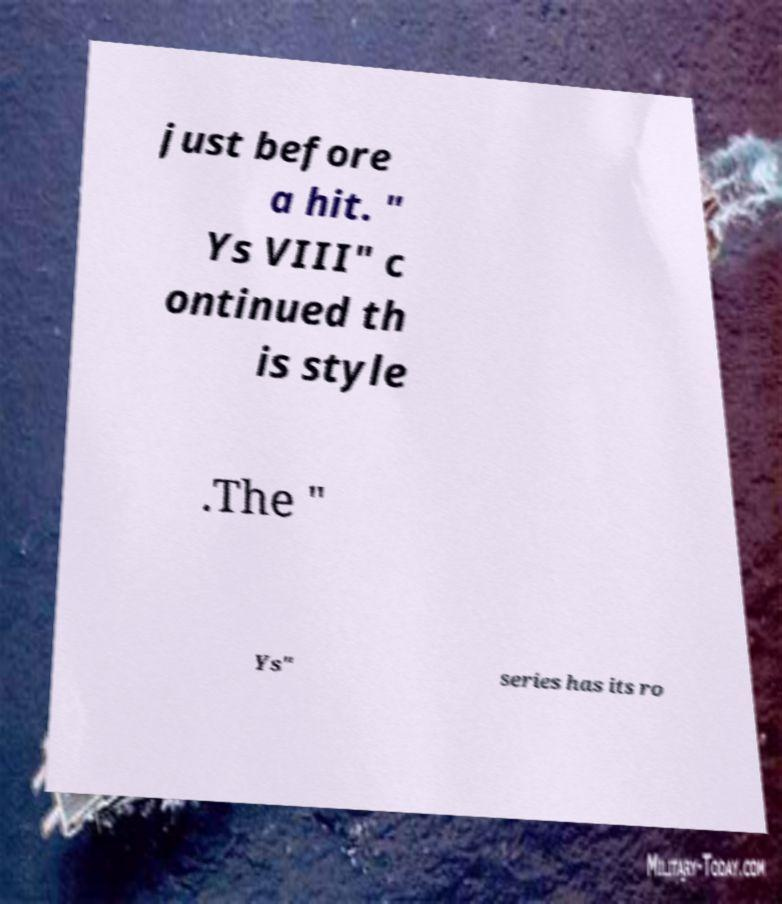What messages or text are displayed in this image? I need them in a readable, typed format. just before a hit. " Ys VIII" c ontinued th is style .The " Ys" series has its ro 